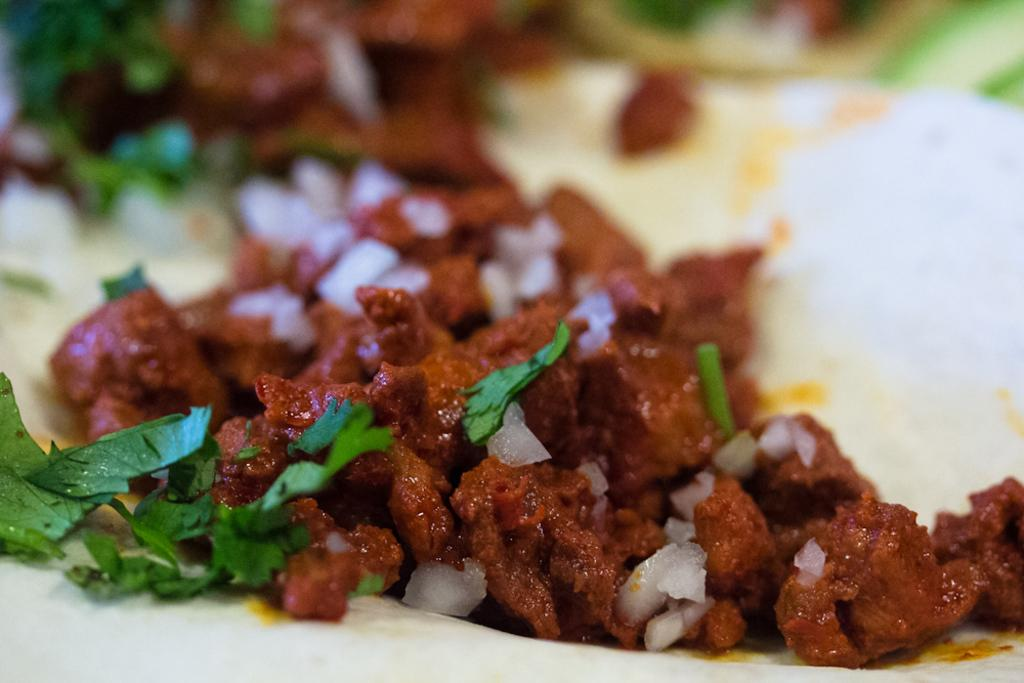What type of food item can be seen in the image? There is a food item with leaf and onion garnish in the image. Can you describe the garnish on the food item? The garnish consists of leaves and onions. Is there another food item visible in the image? Yes, there is another food item in the background of the image, but it is not clearly visible. What type of faucet can be seen in the image? There is no faucet present in the image; it features a food item with leaf and onion garnish. Can you hear the voice of the person who prepared the dish in the image? There is no audio or indication of a person's voice in the image; it is a still photograph of a food item. 